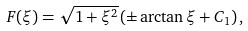<formula> <loc_0><loc_0><loc_500><loc_500>F ( \xi ) = \sqrt { 1 + \xi ^ { 2 } } \left ( \pm \arctan { \xi } + C _ { 1 } \right ) ,</formula> 